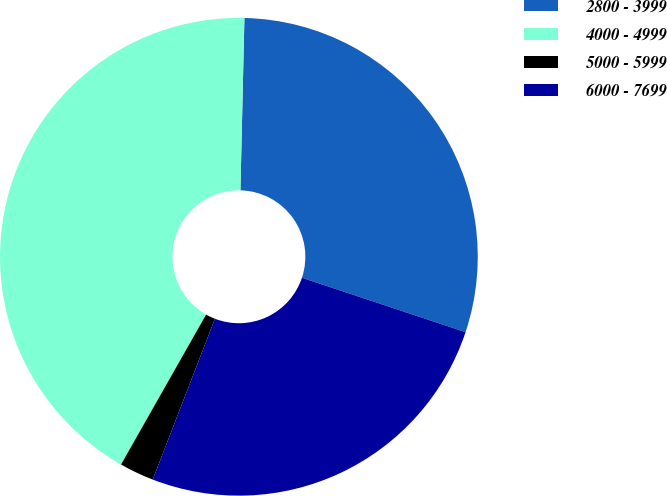Convert chart. <chart><loc_0><loc_0><loc_500><loc_500><pie_chart><fcel>2800 - 3999<fcel>4000 - 4999<fcel>5000 - 5999<fcel>6000 - 7699<nl><fcel>29.74%<fcel>42.15%<fcel>2.34%<fcel>25.76%<nl></chart> 